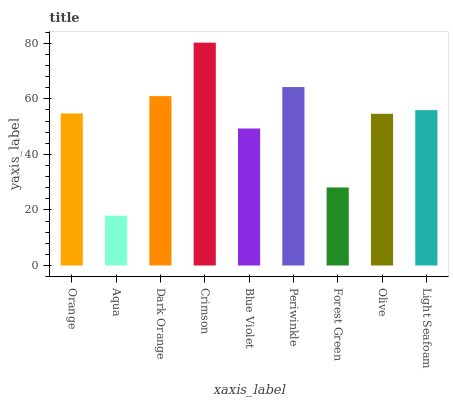Is Aqua the minimum?
Answer yes or no. Yes. Is Crimson the maximum?
Answer yes or no. Yes. Is Dark Orange the minimum?
Answer yes or no. No. Is Dark Orange the maximum?
Answer yes or no. No. Is Dark Orange greater than Aqua?
Answer yes or no. Yes. Is Aqua less than Dark Orange?
Answer yes or no. Yes. Is Aqua greater than Dark Orange?
Answer yes or no. No. Is Dark Orange less than Aqua?
Answer yes or no. No. Is Orange the high median?
Answer yes or no. Yes. Is Orange the low median?
Answer yes or no. Yes. Is Periwinkle the high median?
Answer yes or no. No. Is Periwinkle the low median?
Answer yes or no. No. 